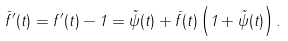Convert formula to latex. <formula><loc_0><loc_0><loc_500><loc_500>\bar { f } ^ { \prime } ( t ) = f ^ { \prime } ( t ) - 1 = \tilde { \psi } ( t ) + \bar { f } ( t ) \left ( 1 + \tilde { \psi } ( t ) \right ) .</formula> 